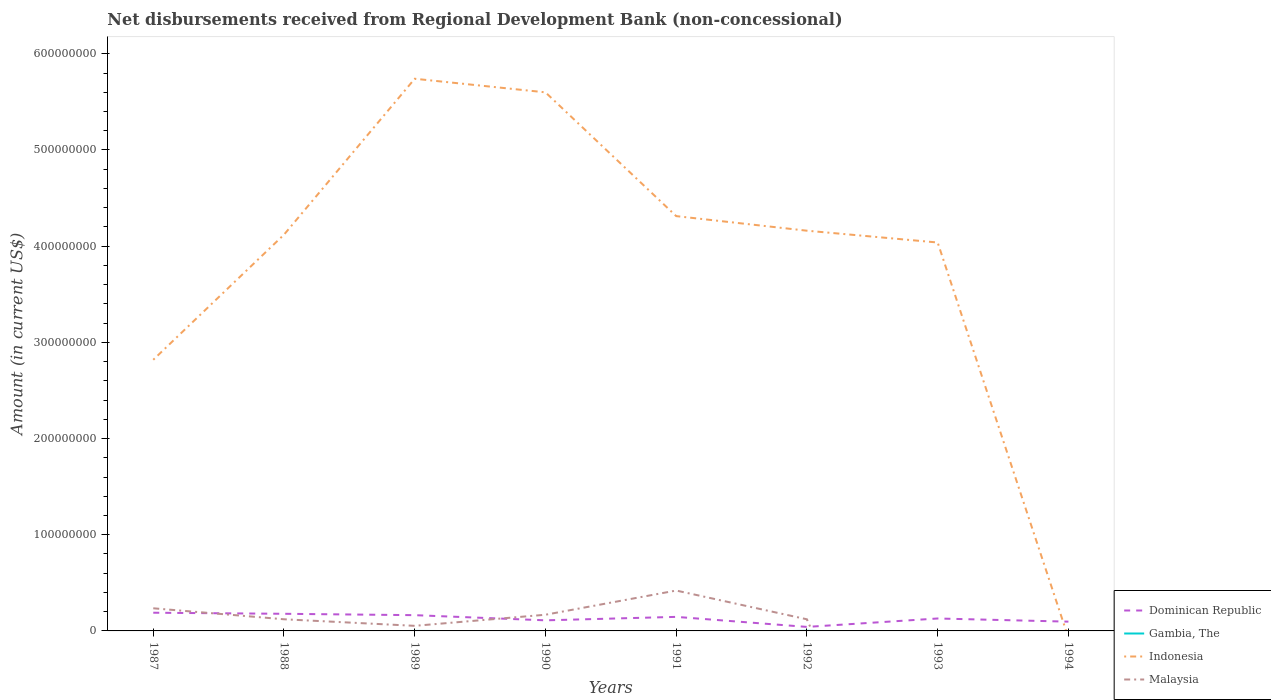Does the line corresponding to Indonesia intersect with the line corresponding to Gambia, The?
Your answer should be compact. Yes. Across all years, what is the maximum amount of disbursements received from Regional Development Bank in Gambia, The?
Make the answer very short. 0. What is the total amount of disbursements received from Regional Development Bank in Dominican Republic in the graph?
Keep it short and to the point. 1.77e+06. What is the difference between the highest and the second highest amount of disbursements received from Regional Development Bank in Malaysia?
Keep it short and to the point. 4.20e+07. What is the difference between the highest and the lowest amount of disbursements received from Regional Development Bank in Indonesia?
Keep it short and to the point. 6. How many lines are there?
Offer a very short reply. 4. How many years are there in the graph?
Offer a very short reply. 8. Does the graph contain any zero values?
Provide a succinct answer. Yes. Does the graph contain grids?
Your answer should be compact. No. What is the title of the graph?
Provide a short and direct response. Net disbursements received from Regional Development Bank (non-concessional). Does "Kiribati" appear as one of the legend labels in the graph?
Offer a terse response. No. What is the Amount (in current US$) in Dominican Republic in 1987?
Keep it short and to the point. 1.89e+07. What is the Amount (in current US$) of Indonesia in 1987?
Your answer should be very brief. 2.82e+08. What is the Amount (in current US$) of Malaysia in 1987?
Provide a succinct answer. 2.35e+07. What is the Amount (in current US$) of Dominican Republic in 1988?
Offer a very short reply. 1.78e+07. What is the Amount (in current US$) of Gambia, The in 1988?
Make the answer very short. 0. What is the Amount (in current US$) in Indonesia in 1988?
Your answer should be very brief. 4.12e+08. What is the Amount (in current US$) of Malaysia in 1988?
Your answer should be compact. 1.21e+07. What is the Amount (in current US$) of Dominican Republic in 1989?
Your response must be concise. 1.64e+07. What is the Amount (in current US$) in Gambia, The in 1989?
Offer a very short reply. 6000. What is the Amount (in current US$) of Indonesia in 1989?
Make the answer very short. 5.74e+08. What is the Amount (in current US$) of Malaysia in 1989?
Ensure brevity in your answer.  5.29e+06. What is the Amount (in current US$) of Dominican Republic in 1990?
Provide a succinct answer. 1.10e+07. What is the Amount (in current US$) in Indonesia in 1990?
Make the answer very short. 5.60e+08. What is the Amount (in current US$) of Malaysia in 1990?
Offer a very short reply. 1.68e+07. What is the Amount (in current US$) in Dominican Republic in 1991?
Ensure brevity in your answer.  1.46e+07. What is the Amount (in current US$) in Gambia, The in 1991?
Make the answer very short. 0. What is the Amount (in current US$) in Indonesia in 1991?
Ensure brevity in your answer.  4.31e+08. What is the Amount (in current US$) in Malaysia in 1991?
Give a very brief answer. 4.20e+07. What is the Amount (in current US$) of Dominican Republic in 1992?
Offer a terse response. 4.17e+06. What is the Amount (in current US$) of Gambia, The in 1992?
Your answer should be very brief. 1.03e+05. What is the Amount (in current US$) of Indonesia in 1992?
Your answer should be very brief. 4.16e+08. What is the Amount (in current US$) in Malaysia in 1992?
Keep it short and to the point. 1.21e+07. What is the Amount (in current US$) of Dominican Republic in 1993?
Provide a succinct answer. 1.29e+07. What is the Amount (in current US$) of Indonesia in 1993?
Give a very brief answer. 4.04e+08. What is the Amount (in current US$) in Dominican Republic in 1994?
Ensure brevity in your answer.  9.64e+06. What is the Amount (in current US$) in Indonesia in 1994?
Your answer should be compact. 0. What is the Amount (in current US$) in Malaysia in 1994?
Your answer should be very brief. 2.62e+06. Across all years, what is the maximum Amount (in current US$) in Dominican Republic?
Provide a short and direct response. 1.89e+07. Across all years, what is the maximum Amount (in current US$) of Gambia, The?
Your answer should be compact. 1.03e+05. Across all years, what is the maximum Amount (in current US$) in Indonesia?
Provide a short and direct response. 5.74e+08. Across all years, what is the maximum Amount (in current US$) of Malaysia?
Offer a very short reply. 4.20e+07. Across all years, what is the minimum Amount (in current US$) of Dominican Republic?
Offer a terse response. 4.17e+06. Across all years, what is the minimum Amount (in current US$) in Malaysia?
Your answer should be compact. 0. What is the total Amount (in current US$) in Dominican Republic in the graph?
Your answer should be very brief. 1.05e+08. What is the total Amount (in current US$) of Gambia, The in the graph?
Give a very brief answer. 1.09e+05. What is the total Amount (in current US$) of Indonesia in the graph?
Offer a terse response. 3.08e+09. What is the total Amount (in current US$) in Malaysia in the graph?
Your answer should be compact. 1.14e+08. What is the difference between the Amount (in current US$) in Dominican Republic in 1987 and that in 1988?
Make the answer very short. 1.11e+06. What is the difference between the Amount (in current US$) in Indonesia in 1987 and that in 1988?
Give a very brief answer. -1.30e+08. What is the difference between the Amount (in current US$) of Malaysia in 1987 and that in 1988?
Your answer should be compact. 1.14e+07. What is the difference between the Amount (in current US$) in Dominican Republic in 1987 and that in 1989?
Your response must be concise. 2.54e+06. What is the difference between the Amount (in current US$) in Indonesia in 1987 and that in 1989?
Ensure brevity in your answer.  -2.92e+08. What is the difference between the Amount (in current US$) of Malaysia in 1987 and that in 1989?
Your answer should be very brief. 1.82e+07. What is the difference between the Amount (in current US$) of Dominican Republic in 1987 and that in 1990?
Keep it short and to the point. 7.91e+06. What is the difference between the Amount (in current US$) of Indonesia in 1987 and that in 1990?
Your answer should be compact. -2.78e+08. What is the difference between the Amount (in current US$) in Malaysia in 1987 and that in 1990?
Provide a short and direct response. 6.70e+06. What is the difference between the Amount (in current US$) in Dominican Republic in 1987 and that in 1991?
Ensure brevity in your answer.  4.32e+06. What is the difference between the Amount (in current US$) in Indonesia in 1987 and that in 1991?
Keep it short and to the point. -1.49e+08. What is the difference between the Amount (in current US$) of Malaysia in 1987 and that in 1991?
Offer a terse response. -1.85e+07. What is the difference between the Amount (in current US$) in Dominican Republic in 1987 and that in 1992?
Offer a very short reply. 1.48e+07. What is the difference between the Amount (in current US$) in Indonesia in 1987 and that in 1992?
Make the answer very short. -1.34e+08. What is the difference between the Amount (in current US$) in Malaysia in 1987 and that in 1992?
Ensure brevity in your answer.  1.15e+07. What is the difference between the Amount (in current US$) of Dominican Republic in 1987 and that in 1993?
Ensure brevity in your answer.  5.99e+06. What is the difference between the Amount (in current US$) of Indonesia in 1987 and that in 1993?
Offer a terse response. -1.22e+08. What is the difference between the Amount (in current US$) in Dominican Republic in 1987 and that in 1994?
Provide a succinct answer. 9.28e+06. What is the difference between the Amount (in current US$) in Malaysia in 1987 and that in 1994?
Your answer should be compact. 2.09e+07. What is the difference between the Amount (in current US$) of Dominican Republic in 1988 and that in 1989?
Your response must be concise. 1.43e+06. What is the difference between the Amount (in current US$) of Indonesia in 1988 and that in 1989?
Your answer should be compact. -1.62e+08. What is the difference between the Amount (in current US$) in Malaysia in 1988 and that in 1989?
Your answer should be very brief. 6.82e+06. What is the difference between the Amount (in current US$) of Dominican Republic in 1988 and that in 1990?
Offer a terse response. 6.80e+06. What is the difference between the Amount (in current US$) of Indonesia in 1988 and that in 1990?
Keep it short and to the point. -1.48e+08. What is the difference between the Amount (in current US$) in Malaysia in 1988 and that in 1990?
Your answer should be compact. -4.72e+06. What is the difference between the Amount (in current US$) of Dominican Republic in 1988 and that in 1991?
Offer a very short reply. 3.21e+06. What is the difference between the Amount (in current US$) of Indonesia in 1988 and that in 1991?
Make the answer very short. -1.93e+07. What is the difference between the Amount (in current US$) of Malaysia in 1988 and that in 1991?
Ensure brevity in your answer.  -2.99e+07. What is the difference between the Amount (in current US$) in Dominican Republic in 1988 and that in 1992?
Ensure brevity in your answer.  1.36e+07. What is the difference between the Amount (in current US$) of Indonesia in 1988 and that in 1992?
Your answer should be very brief. -4.12e+06. What is the difference between the Amount (in current US$) of Malaysia in 1988 and that in 1992?
Give a very brief answer. 3.40e+04. What is the difference between the Amount (in current US$) in Dominican Republic in 1988 and that in 1993?
Your answer should be very brief. 4.88e+06. What is the difference between the Amount (in current US$) of Indonesia in 1988 and that in 1993?
Ensure brevity in your answer.  8.15e+06. What is the difference between the Amount (in current US$) in Dominican Republic in 1988 and that in 1994?
Your response must be concise. 8.17e+06. What is the difference between the Amount (in current US$) of Malaysia in 1988 and that in 1994?
Your answer should be compact. 9.48e+06. What is the difference between the Amount (in current US$) in Dominican Republic in 1989 and that in 1990?
Give a very brief answer. 5.37e+06. What is the difference between the Amount (in current US$) of Indonesia in 1989 and that in 1990?
Ensure brevity in your answer.  1.41e+07. What is the difference between the Amount (in current US$) in Malaysia in 1989 and that in 1990?
Give a very brief answer. -1.15e+07. What is the difference between the Amount (in current US$) of Dominican Republic in 1989 and that in 1991?
Provide a short and direct response. 1.77e+06. What is the difference between the Amount (in current US$) of Indonesia in 1989 and that in 1991?
Ensure brevity in your answer.  1.43e+08. What is the difference between the Amount (in current US$) of Malaysia in 1989 and that in 1991?
Your response must be concise. -3.67e+07. What is the difference between the Amount (in current US$) in Dominican Republic in 1989 and that in 1992?
Your answer should be compact. 1.22e+07. What is the difference between the Amount (in current US$) of Gambia, The in 1989 and that in 1992?
Offer a very short reply. -9.70e+04. What is the difference between the Amount (in current US$) in Indonesia in 1989 and that in 1992?
Your answer should be very brief. 1.58e+08. What is the difference between the Amount (in current US$) in Malaysia in 1989 and that in 1992?
Your response must be concise. -6.78e+06. What is the difference between the Amount (in current US$) of Dominican Republic in 1989 and that in 1993?
Offer a very short reply. 3.45e+06. What is the difference between the Amount (in current US$) in Indonesia in 1989 and that in 1993?
Your answer should be very brief. 1.70e+08. What is the difference between the Amount (in current US$) of Dominican Republic in 1989 and that in 1994?
Keep it short and to the point. 6.74e+06. What is the difference between the Amount (in current US$) in Malaysia in 1989 and that in 1994?
Your response must be concise. 2.67e+06. What is the difference between the Amount (in current US$) in Dominican Republic in 1990 and that in 1991?
Give a very brief answer. -3.60e+06. What is the difference between the Amount (in current US$) of Indonesia in 1990 and that in 1991?
Your answer should be compact. 1.29e+08. What is the difference between the Amount (in current US$) of Malaysia in 1990 and that in 1991?
Provide a succinct answer. -2.52e+07. What is the difference between the Amount (in current US$) of Dominican Republic in 1990 and that in 1992?
Give a very brief answer. 6.84e+06. What is the difference between the Amount (in current US$) in Indonesia in 1990 and that in 1992?
Your answer should be very brief. 1.44e+08. What is the difference between the Amount (in current US$) in Malaysia in 1990 and that in 1992?
Give a very brief answer. 4.75e+06. What is the difference between the Amount (in current US$) of Dominican Republic in 1990 and that in 1993?
Your answer should be compact. -1.92e+06. What is the difference between the Amount (in current US$) of Indonesia in 1990 and that in 1993?
Ensure brevity in your answer.  1.56e+08. What is the difference between the Amount (in current US$) of Dominican Republic in 1990 and that in 1994?
Make the answer very short. 1.37e+06. What is the difference between the Amount (in current US$) in Malaysia in 1990 and that in 1994?
Provide a succinct answer. 1.42e+07. What is the difference between the Amount (in current US$) of Dominican Republic in 1991 and that in 1992?
Give a very brief answer. 1.04e+07. What is the difference between the Amount (in current US$) of Indonesia in 1991 and that in 1992?
Offer a very short reply. 1.52e+07. What is the difference between the Amount (in current US$) of Malaysia in 1991 and that in 1992?
Offer a terse response. 2.99e+07. What is the difference between the Amount (in current US$) in Dominican Republic in 1991 and that in 1993?
Your response must be concise. 1.68e+06. What is the difference between the Amount (in current US$) of Indonesia in 1991 and that in 1993?
Provide a short and direct response. 2.74e+07. What is the difference between the Amount (in current US$) of Dominican Republic in 1991 and that in 1994?
Your answer should be very brief. 4.96e+06. What is the difference between the Amount (in current US$) of Malaysia in 1991 and that in 1994?
Provide a succinct answer. 3.94e+07. What is the difference between the Amount (in current US$) in Dominican Republic in 1992 and that in 1993?
Your answer should be very brief. -8.76e+06. What is the difference between the Amount (in current US$) in Indonesia in 1992 and that in 1993?
Your response must be concise. 1.23e+07. What is the difference between the Amount (in current US$) of Dominican Republic in 1992 and that in 1994?
Ensure brevity in your answer.  -5.47e+06. What is the difference between the Amount (in current US$) in Malaysia in 1992 and that in 1994?
Your answer should be very brief. 9.45e+06. What is the difference between the Amount (in current US$) of Dominican Republic in 1993 and that in 1994?
Keep it short and to the point. 3.29e+06. What is the difference between the Amount (in current US$) in Dominican Republic in 1987 and the Amount (in current US$) in Indonesia in 1988?
Give a very brief answer. -3.93e+08. What is the difference between the Amount (in current US$) in Dominican Republic in 1987 and the Amount (in current US$) in Malaysia in 1988?
Keep it short and to the point. 6.81e+06. What is the difference between the Amount (in current US$) of Indonesia in 1987 and the Amount (in current US$) of Malaysia in 1988?
Provide a short and direct response. 2.70e+08. What is the difference between the Amount (in current US$) in Dominican Republic in 1987 and the Amount (in current US$) in Gambia, The in 1989?
Give a very brief answer. 1.89e+07. What is the difference between the Amount (in current US$) of Dominican Republic in 1987 and the Amount (in current US$) of Indonesia in 1989?
Offer a very short reply. -5.55e+08. What is the difference between the Amount (in current US$) of Dominican Republic in 1987 and the Amount (in current US$) of Malaysia in 1989?
Ensure brevity in your answer.  1.36e+07. What is the difference between the Amount (in current US$) of Indonesia in 1987 and the Amount (in current US$) of Malaysia in 1989?
Provide a succinct answer. 2.77e+08. What is the difference between the Amount (in current US$) of Dominican Republic in 1987 and the Amount (in current US$) of Indonesia in 1990?
Provide a succinct answer. -5.41e+08. What is the difference between the Amount (in current US$) of Dominican Republic in 1987 and the Amount (in current US$) of Malaysia in 1990?
Provide a succinct answer. 2.09e+06. What is the difference between the Amount (in current US$) of Indonesia in 1987 and the Amount (in current US$) of Malaysia in 1990?
Your answer should be very brief. 2.65e+08. What is the difference between the Amount (in current US$) of Dominican Republic in 1987 and the Amount (in current US$) of Indonesia in 1991?
Your answer should be very brief. -4.12e+08. What is the difference between the Amount (in current US$) of Dominican Republic in 1987 and the Amount (in current US$) of Malaysia in 1991?
Your response must be concise. -2.31e+07. What is the difference between the Amount (in current US$) of Indonesia in 1987 and the Amount (in current US$) of Malaysia in 1991?
Provide a succinct answer. 2.40e+08. What is the difference between the Amount (in current US$) in Dominican Republic in 1987 and the Amount (in current US$) in Gambia, The in 1992?
Your answer should be compact. 1.88e+07. What is the difference between the Amount (in current US$) of Dominican Republic in 1987 and the Amount (in current US$) of Indonesia in 1992?
Keep it short and to the point. -3.97e+08. What is the difference between the Amount (in current US$) of Dominican Republic in 1987 and the Amount (in current US$) of Malaysia in 1992?
Ensure brevity in your answer.  6.84e+06. What is the difference between the Amount (in current US$) in Indonesia in 1987 and the Amount (in current US$) in Malaysia in 1992?
Ensure brevity in your answer.  2.70e+08. What is the difference between the Amount (in current US$) in Dominican Republic in 1987 and the Amount (in current US$) in Indonesia in 1993?
Provide a short and direct response. -3.85e+08. What is the difference between the Amount (in current US$) of Dominican Republic in 1987 and the Amount (in current US$) of Malaysia in 1994?
Ensure brevity in your answer.  1.63e+07. What is the difference between the Amount (in current US$) of Indonesia in 1987 and the Amount (in current US$) of Malaysia in 1994?
Your answer should be very brief. 2.79e+08. What is the difference between the Amount (in current US$) of Dominican Republic in 1988 and the Amount (in current US$) of Gambia, The in 1989?
Your answer should be very brief. 1.78e+07. What is the difference between the Amount (in current US$) of Dominican Republic in 1988 and the Amount (in current US$) of Indonesia in 1989?
Make the answer very short. -5.56e+08. What is the difference between the Amount (in current US$) in Dominican Republic in 1988 and the Amount (in current US$) in Malaysia in 1989?
Ensure brevity in your answer.  1.25e+07. What is the difference between the Amount (in current US$) in Indonesia in 1988 and the Amount (in current US$) in Malaysia in 1989?
Provide a succinct answer. 4.07e+08. What is the difference between the Amount (in current US$) in Dominican Republic in 1988 and the Amount (in current US$) in Indonesia in 1990?
Your answer should be very brief. -5.42e+08. What is the difference between the Amount (in current US$) of Dominican Republic in 1988 and the Amount (in current US$) of Malaysia in 1990?
Offer a very short reply. 9.82e+05. What is the difference between the Amount (in current US$) in Indonesia in 1988 and the Amount (in current US$) in Malaysia in 1990?
Ensure brevity in your answer.  3.95e+08. What is the difference between the Amount (in current US$) in Dominican Republic in 1988 and the Amount (in current US$) in Indonesia in 1991?
Provide a succinct answer. -4.13e+08. What is the difference between the Amount (in current US$) of Dominican Republic in 1988 and the Amount (in current US$) of Malaysia in 1991?
Provide a short and direct response. -2.42e+07. What is the difference between the Amount (in current US$) in Indonesia in 1988 and the Amount (in current US$) in Malaysia in 1991?
Your response must be concise. 3.70e+08. What is the difference between the Amount (in current US$) in Dominican Republic in 1988 and the Amount (in current US$) in Gambia, The in 1992?
Keep it short and to the point. 1.77e+07. What is the difference between the Amount (in current US$) of Dominican Republic in 1988 and the Amount (in current US$) of Indonesia in 1992?
Ensure brevity in your answer.  -3.98e+08. What is the difference between the Amount (in current US$) in Dominican Republic in 1988 and the Amount (in current US$) in Malaysia in 1992?
Offer a terse response. 5.74e+06. What is the difference between the Amount (in current US$) of Indonesia in 1988 and the Amount (in current US$) of Malaysia in 1992?
Offer a very short reply. 4.00e+08. What is the difference between the Amount (in current US$) of Dominican Republic in 1988 and the Amount (in current US$) of Indonesia in 1993?
Your answer should be compact. -3.86e+08. What is the difference between the Amount (in current US$) of Dominican Republic in 1988 and the Amount (in current US$) of Malaysia in 1994?
Provide a short and direct response. 1.52e+07. What is the difference between the Amount (in current US$) in Indonesia in 1988 and the Amount (in current US$) in Malaysia in 1994?
Provide a short and direct response. 4.09e+08. What is the difference between the Amount (in current US$) of Dominican Republic in 1989 and the Amount (in current US$) of Indonesia in 1990?
Provide a short and direct response. -5.44e+08. What is the difference between the Amount (in current US$) in Dominican Republic in 1989 and the Amount (in current US$) in Malaysia in 1990?
Offer a very short reply. -4.51e+05. What is the difference between the Amount (in current US$) in Gambia, The in 1989 and the Amount (in current US$) in Indonesia in 1990?
Provide a succinct answer. -5.60e+08. What is the difference between the Amount (in current US$) of Gambia, The in 1989 and the Amount (in current US$) of Malaysia in 1990?
Your answer should be very brief. -1.68e+07. What is the difference between the Amount (in current US$) of Indonesia in 1989 and the Amount (in current US$) of Malaysia in 1990?
Provide a succinct answer. 5.57e+08. What is the difference between the Amount (in current US$) in Dominican Republic in 1989 and the Amount (in current US$) in Indonesia in 1991?
Offer a terse response. -4.15e+08. What is the difference between the Amount (in current US$) in Dominican Republic in 1989 and the Amount (in current US$) in Malaysia in 1991?
Give a very brief answer. -2.56e+07. What is the difference between the Amount (in current US$) of Gambia, The in 1989 and the Amount (in current US$) of Indonesia in 1991?
Your response must be concise. -4.31e+08. What is the difference between the Amount (in current US$) in Gambia, The in 1989 and the Amount (in current US$) in Malaysia in 1991?
Provide a short and direct response. -4.20e+07. What is the difference between the Amount (in current US$) in Indonesia in 1989 and the Amount (in current US$) in Malaysia in 1991?
Your answer should be very brief. 5.32e+08. What is the difference between the Amount (in current US$) in Dominican Republic in 1989 and the Amount (in current US$) in Gambia, The in 1992?
Give a very brief answer. 1.63e+07. What is the difference between the Amount (in current US$) in Dominican Republic in 1989 and the Amount (in current US$) in Indonesia in 1992?
Offer a terse response. -4.00e+08. What is the difference between the Amount (in current US$) in Dominican Republic in 1989 and the Amount (in current US$) in Malaysia in 1992?
Your answer should be very brief. 4.30e+06. What is the difference between the Amount (in current US$) of Gambia, The in 1989 and the Amount (in current US$) of Indonesia in 1992?
Offer a very short reply. -4.16e+08. What is the difference between the Amount (in current US$) in Gambia, The in 1989 and the Amount (in current US$) in Malaysia in 1992?
Your answer should be compact. -1.21e+07. What is the difference between the Amount (in current US$) of Indonesia in 1989 and the Amount (in current US$) of Malaysia in 1992?
Ensure brevity in your answer.  5.62e+08. What is the difference between the Amount (in current US$) of Dominican Republic in 1989 and the Amount (in current US$) of Indonesia in 1993?
Your answer should be compact. -3.87e+08. What is the difference between the Amount (in current US$) of Gambia, The in 1989 and the Amount (in current US$) of Indonesia in 1993?
Make the answer very short. -4.04e+08. What is the difference between the Amount (in current US$) in Dominican Republic in 1989 and the Amount (in current US$) in Malaysia in 1994?
Provide a succinct answer. 1.38e+07. What is the difference between the Amount (in current US$) of Gambia, The in 1989 and the Amount (in current US$) of Malaysia in 1994?
Provide a short and direct response. -2.62e+06. What is the difference between the Amount (in current US$) in Indonesia in 1989 and the Amount (in current US$) in Malaysia in 1994?
Make the answer very short. 5.71e+08. What is the difference between the Amount (in current US$) in Dominican Republic in 1990 and the Amount (in current US$) in Indonesia in 1991?
Keep it short and to the point. -4.20e+08. What is the difference between the Amount (in current US$) of Dominican Republic in 1990 and the Amount (in current US$) of Malaysia in 1991?
Your response must be concise. -3.10e+07. What is the difference between the Amount (in current US$) in Indonesia in 1990 and the Amount (in current US$) in Malaysia in 1991?
Offer a very short reply. 5.18e+08. What is the difference between the Amount (in current US$) of Dominican Republic in 1990 and the Amount (in current US$) of Gambia, The in 1992?
Your answer should be very brief. 1.09e+07. What is the difference between the Amount (in current US$) in Dominican Republic in 1990 and the Amount (in current US$) in Indonesia in 1992?
Make the answer very short. -4.05e+08. What is the difference between the Amount (in current US$) in Dominican Republic in 1990 and the Amount (in current US$) in Malaysia in 1992?
Ensure brevity in your answer.  -1.07e+06. What is the difference between the Amount (in current US$) of Indonesia in 1990 and the Amount (in current US$) of Malaysia in 1992?
Offer a terse response. 5.48e+08. What is the difference between the Amount (in current US$) of Dominican Republic in 1990 and the Amount (in current US$) of Indonesia in 1993?
Your response must be concise. -3.93e+08. What is the difference between the Amount (in current US$) in Dominican Republic in 1990 and the Amount (in current US$) in Malaysia in 1994?
Keep it short and to the point. 8.38e+06. What is the difference between the Amount (in current US$) in Indonesia in 1990 and the Amount (in current US$) in Malaysia in 1994?
Keep it short and to the point. 5.57e+08. What is the difference between the Amount (in current US$) in Dominican Republic in 1991 and the Amount (in current US$) in Gambia, The in 1992?
Make the answer very short. 1.45e+07. What is the difference between the Amount (in current US$) in Dominican Republic in 1991 and the Amount (in current US$) in Indonesia in 1992?
Offer a very short reply. -4.01e+08. What is the difference between the Amount (in current US$) of Dominican Republic in 1991 and the Amount (in current US$) of Malaysia in 1992?
Provide a short and direct response. 2.53e+06. What is the difference between the Amount (in current US$) in Indonesia in 1991 and the Amount (in current US$) in Malaysia in 1992?
Provide a short and direct response. 4.19e+08. What is the difference between the Amount (in current US$) of Dominican Republic in 1991 and the Amount (in current US$) of Indonesia in 1993?
Your response must be concise. -3.89e+08. What is the difference between the Amount (in current US$) of Dominican Republic in 1991 and the Amount (in current US$) of Malaysia in 1994?
Your answer should be compact. 1.20e+07. What is the difference between the Amount (in current US$) of Indonesia in 1991 and the Amount (in current US$) of Malaysia in 1994?
Your answer should be compact. 4.29e+08. What is the difference between the Amount (in current US$) of Dominican Republic in 1992 and the Amount (in current US$) of Indonesia in 1993?
Offer a very short reply. -4.00e+08. What is the difference between the Amount (in current US$) in Gambia, The in 1992 and the Amount (in current US$) in Indonesia in 1993?
Your response must be concise. -4.04e+08. What is the difference between the Amount (in current US$) of Dominican Republic in 1992 and the Amount (in current US$) of Malaysia in 1994?
Offer a terse response. 1.55e+06. What is the difference between the Amount (in current US$) of Gambia, The in 1992 and the Amount (in current US$) of Malaysia in 1994?
Provide a short and direct response. -2.52e+06. What is the difference between the Amount (in current US$) in Indonesia in 1992 and the Amount (in current US$) in Malaysia in 1994?
Provide a short and direct response. 4.13e+08. What is the difference between the Amount (in current US$) in Dominican Republic in 1993 and the Amount (in current US$) in Malaysia in 1994?
Offer a terse response. 1.03e+07. What is the difference between the Amount (in current US$) in Indonesia in 1993 and the Amount (in current US$) in Malaysia in 1994?
Your response must be concise. 4.01e+08. What is the average Amount (in current US$) of Dominican Republic per year?
Make the answer very short. 1.32e+07. What is the average Amount (in current US$) in Gambia, The per year?
Make the answer very short. 1.36e+04. What is the average Amount (in current US$) in Indonesia per year?
Give a very brief answer. 3.85e+08. What is the average Amount (in current US$) of Malaysia per year?
Give a very brief answer. 1.43e+07. In the year 1987, what is the difference between the Amount (in current US$) of Dominican Republic and Amount (in current US$) of Indonesia?
Ensure brevity in your answer.  -2.63e+08. In the year 1987, what is the difference between the Amount (in current US$) of Dominican Republic and Amount (in current US$) of Malaysia?
Give a very brief answer. -4.61e+06. In the year 1987, what is the difference between the Amount (in current US$) in Indonesia and Amount (in current US$) in Malaysia?
Provide a succinct answer. 2.58e+08. In the year 1988, what is the difference between the Amount (in current US$) of Dominican Republic and Amount (in current US$) of Indonesia?
Make the answer very short. -3.94e+08. In the year 1988, what is the difference between the Amount (in current US$) of Dominican Republic and Amount (in current US$) of Malaysia?
Keep it short and to the point. 5.70e+06. In the year 1988, what is the difference between the Amount (in current US$) of Indonesia and Amount (in current US$) of Malaysia?
Provide a succinct answer. 4.00e+08. In the year 1989, what is the difference between the Amount (in current US$) in Dominican Republic and Amount (in current US$) in Gambia, The?
Make the answer very short. 1.64e+07. In the year 1989, what is the difference between the Amount (in current US$) in Dominican Republic and Amount (in current US$) in Indonesia?
Your answer should be compact. -5.58e+08. In the year 1989, what is the difference between the Amount (in current US$) in Dominican Republic and Amount (in current US$) in Malaysia?
Provide a succinct answer. 1.11e+07. In the year 1989, what is the difference between the Amount (in current US$) of Gambia, The and Amount (in current US$) of Indonesia?
Provide a succinct answer. -5.74e+08. In the year 1989, what is the difference between the Amount (in current US$) of Gambia, The and Amount (in current US$) of Malaysia?
Offer a terse response. -5.28e+06. In the year 1989, what is the difference between the Amount (in current US$) of Indonesia and Amount (in current US$) of Malaysia?
Keep it short and to the point. 5.69e+08. In the year 1990, what is the difference between the Amount (in current US$) in Dominican Republic and Amount (in current US$) in Indonesia?
Give a very brief answer. -5.49e+08. In the year 1990, what is the difference between the Amount (in current US$) of Dominican Republic and Amount (in current US$) of Malaysia?
Give a very brief answer. -5.82e+06. In the year 1990, what is the difference between the Amount (in current US$) in Indonesia and Amount (in current US$) in Malaysia?
Your response must be concise. 5.43e+08. In the year 1991, what is the difference between the Amount (in current US$) of Dominican Republic and Amount (in current US$) of Indonesia?
Keep it short and to the point. -4.17e+08. In the year 1991, what is the difference between the Amount (in current US$) of Dominican Republic and Amount (in current US$) of Malaysia?
Offer a very short reply. -2.74e+07. In the year 1991, what is the difference between the Amount (in current US$) of Indonesia and Amount (in current US$) of Malaysia?
Provide a short and direct response. 3.89e+08. In the year 1992, what is the difference between the Amount (in current US$) of Dominican Republic and Amount (in current US$) of Gambia, The?
Ensure brevity in your answer.  4.07e+06. In the year 1992, what is the difference between the Amount (in current US$) in Dominican Republic and Amount (in current US$) in Indonesia?
Provide a short and direct response. -4.12e+08. In the year 1992, what is the difference between the Amount (in current US$) of Dominican Republic and Amount (in current US$) of Malaysia?
Keep it short and to the point. -7.90e+06. In the year 1992, what is the difference between the Amount (in current US$) in Gambia, The and Amount (in current US$) in Indonesia?
Your response must be concise. -4.16e+08. In the year 1992, what is the difference between the Amount (in current US$) of Gambia, The and Amount (in current US$) of Malaysia?
Give a very brief answer. -1.20e+07. In the year 1992, what is the difference between the Amount (in current US$) in Indonesia and Amount (in current US$) in Malaysia?
Provide a short and direct response. 4.04e+08. In the year 1993, what is the difference between the Amount (in current US$) of Dominican Republic and Amount (in current US$) of Indonesia?
Ensure brevity in your answer.  -3.91e+08. In the year 1994, what is the difference between the Amount (in current US$) in Dominican Republic and Amount (in current US$) in Malaysia?
Offer a terse response. 7.02e+06. What is the ratio of the Amount (in current US$) in Dominican Republic in 1987 to that in 1988?
Your answer should be very brief. 1.06. What is the ratio of the Amount (in current US$) of Indonesia in 1987 to that in 1988?
Provide a succinct answer. 0.68. What is the ratio of the Amount (in current US$) in Malaysia in 1987 to that in 1988?
Offer a very short reply. 1.94. What is the ratio of the Amount (in current US$) of Dominican Republic in 1987 to that in 1989?
Ensure brevity in your answer.  1.16. What is the ratio of the Amount (in current US$) of Indonesia in 1987 to that in 1989?
Your answer should be very brief. 0.49. What is the ratio of the Amount (in current US$) in Malaysia in 1987 to that in 1989?
Provide a short and direct response. 4.45. What is the ratio of the Amount (in current US$) in Dominican Republic in 1987 to that in 1990?
Ensure brevity in your answer.  1.72. What is the ratio of the Amount (in current US$) of Indonesia in 1987 to that in 1990?
Ensure brevity in your answer.  0.5. What is the ratio of the Amount (in current US$) of Malaysia in 1987 to that in 1990?
Keep it short and to the point. 1.4. What is the ratio of the Amount (in current US$) in Dominican Republic in 1987 to that in 1991?
Your answer should be compact. 1.3. What is the ratio of the Amount (in current US$) of Indonesia in 1987 to that in 1991?
Your answer should be compact. 0.65. What is the ratio of the Amount (in current US$) of Malaysia in 1987 to that in 1991?
Provide a short and direct response. 0.56. What is the ratio of the Amount (in current US$) of Dominican Republic in 1987 to that in 1992?
Give a very brief answer. 4.54. What is the ratio of the Amount (in current US$) of Indonesia in 1987 to that in 1992?
Offer a very short reply. 0.68. What is the ratio of the Amount (in current US$) in Malaysia in 1987 to that in 1992?
Ensure brevity in your answer.  1.95. What is the ratio of the Amount (in current US$) of Dominican Republic in 1987 to that in 1993?
Your answer should be compact. 1.46. What is the ratio of the Amount (in current US$) in Indonesia in 1987 to that in 1993?
Your answer should be compact. 0.7. What is the ratio of the Amount (in current US$) in Dominican Republic in 1987 to that in 1994?
Give a very brief answer. 1.96. What is the ratio of the Amount (in current US$) in Malaysia in 1987 to that in 1994?
Ensure brevity in your answer.  8.97. What is the ratio of the Amount (in current US$) of Dominican Republic in 1988 to that in 1989?
Your answer should be very brief. 1.09. What is the ratio of the Amount (in current US$) of Indonesia in 1988 to that in 1989?
Provide a succinct answer. 0.72. What is the ratio of the Amount (in current US$) in Malaysia in 1988 to that in 1989?
Keep it short and to the point. 2.29. What is the ratio of the Amount (in current US$) of Dominican Republic in 1988 to that in 1990?
Ensure brevity in your answer.  1.62. What is the ratio of the Amount (in current US$) in Indonesia in 1988 to that in 1990?
Your answer should be very brief. 0.74. What is the ratio of the Amount (in current US$) in Malaysia in 1988 to that in 1990?
Keep it short and to the point. 0.72. What is the ratio of the Amount (in current US$) in Dominican Republic in 1988 to that in 1991?
Ensure brevity in your answer.  1.22. What is the ratio of the Amount (in current US$) in Indonesia in 1988 to that in 1991?
Make the answer very short. 0.96. What is the ratio of the Amount (in current US$) of Malaysia in 1988 to that in 1991?
Your answer should be compact. 0.29. What is the ratio of the Amount (in current US$) of Dominican Republic in 1988 to that in 1992?
Keep it short and to the point. 4.27. What is the ratio of the Amount (in current US$) in Dominican Republic in 1988 to that in 1993?
Provide a succinct answer. 1.38. What is the ratio of the Amount (in current US$) of Indonesia in 1988 to that in 1993?
Provide a short and direct response. 1.02. What is the ratio of the Amount (in current US$) of Dominican Republic in 1988 to that in 1994?
Your answer should be very brief. 1.85. What is the ratio of the Amount (in current US$) in Malaysia in 1988 to that in 1994?
Keep it short and to the point. 4.61. What is the ratio of the Amount (in current US$) of Dominican Republic in 1989 to that in 1990?
Your answer should be very brief. 1.49. What is the ratio of the Amount (in current US$) in Indonesia in 1989 to that in 1990?
Your answer should be compact. 1.03. What is the ratio of the Amount (in current US$) in Malaysia in 1989 to that in 1990?
Your answer should be compact. 0.31. What is the ratio of the Amount (in current US$) of Dominican Republic in 1989 to that in 1991?
Your response must be concise. 1.12. What is the ratio of the Amount (in current US$) of Indonesia in 1989 to that in 1991?
Make the answer very short. 1.33. What is the ratio of the Amount (in current US$) in Malaysia in 1989 to that in 1991?
Provide a succinct answer. 0.13. What is the ratio of the Amount (in current US$) of Dominican Republic in 1989 to that in 1992?
Keep it short and to the point. 3.93. What is the ratio of the Amount (in current US$) in Gambia, The in 1989 to that in 1992?
Give a very brief answer. 0.06. What is the ratio of the Amount (in current US$) of Indonesia in 1989 to that in 1992?
Provide a short and direct response. 1.38. What is the ratio of the Amount (in current US$) of Malaysia in 1989 to that in 1992?
Your answer should be very brief. 0.44. What is the ratio of the Amount (in current US$) in Dominican Republic in 1989 to that in 1993?
Your response must be concise. 1.27. What is the ratio of the Amount (in current US$) in Indonesia in 1989 to that in 1993?
Provide a short and direct response. 1.42. What is the ratio of the Amount (in current US$) in Dominican Republic in 1989 to that in 1994?
Your response must be concise. 1.7. What is the ratio of the Amount (in current US$) in Malaysia in 1989 to that in 1994?
Provide a succinct answer. 2.02. What is the ratio of the Amount (in current US$) in Dominican Republic in 1990 to that in 1991?
Make the answer very short. 0.75. What is the ratio of the Amount (in current US$) in Indonesia in 1990 to that in 1991?
Your response must be concise. 1.3. What is the ratio of the Amount (in current US$) in Malaysia in 1990 to that in 1991?
Keep it short and to the point. 0.4. What is the ratio of the Amount (in current US$) of Dominican Republic in 1990 to that in 1992?
Your response must be concise. 2.64. What is the ratio of the Amount (in current US$) of Indonesia in 1990 to that in 1992?
Your answer should be compact. 1.35. What is the ratio of the Amount (in current US$) in Malaysia in 1990 to that in 1992?
Your answer should be compact. 1.39. What is the ratio of the Amount (in current US$) of Dominican Republic in 1990 to that in 1993?
Offer a terse response. 0.85. What is the ratio of the Amount (in current US$) in Indonesia in 1990 to that in 1993?
Make the answer very short. 1.39. What is the ratio of the Amount (in current US$) of Dominican Republic in 1990 to that in 1994?
Offer a terse response. 1.14. What is the ratio of the Amount (in current US$) in Malaysia in 1990 to that in 1994?
Provide a succinct answer. 6.41. What is the ratio of the Amount (in current US$) of Dominican Republic in 1991 to that in 1992?
Make the answer very short. 3.5. What is the ratio of the Amount (in current US$) of Indonesia in 1991 to that in 1992?
Ensure brevity in your answer.  1.04. What is the ratio of the Amount (in current US$) of Malaysia in 1991 to that in 1992?
Provide a short and direct response. 3.48. What is the ratio of the Amount (in current US$) of Dominican Republic in 1991 to that in 1993?
Your response must be concise. 1.13. What is the ratio of the Amount (in current US$) in Indonesia in 1991 to that in 1993?
Your response must be concise. 1.07. What is the ratio of the Amount (in current US$) of Dominican Republic in 1991 to that in 1994?
Keep it short and to the point. 1.51. What is the ratio of the Amount (in current US$) of Malaysia in 1991 to that in 1994?
Provide a succinct answer. 16. What is the ratio of the Amount (in current US$) of Dominican Republic in 1992 to that in 1993?
Offer a very short reply. 0.32. What is the ratio of the Amount (in current US$) in Indonesia in 1992 to that in 1993?
Ensure brevity in your answer.  1.03. What is the ratio of the Amount (in current US$) of Dominican Republic in 1992 to that in 1994?
Keep it short and to the point. 0.43. What is the ratio of the Amount (in current US$) of Malaysia in 1992 to that in 1994?
Ensure brevity in your answer.  4.6. What is the ratio of the Amount (in current US$) in Dominican Republic in 1993 to that in 1994?
Your response must be concise. 1.34. What is the difference between the highest and the second highest Amount (in current US$) in Dominican Republic?
Make the answer very short. 1.11e+06. What is the difference between the highest and the second highest Amount (in current US$) of Indonesia?
Provide a short and direct response. 1.41e+07. What is the difference between the highest and the second highest Amount (in current US$) in Malaysia?
Your response must be concise. 1.85e+07. What is the difference between the highest and the lowest Amount (in current US$) in Dominican Republic?
Make the answer very short. 1.48e+07. What is the difference between the highest and the lowest Amount (in current US$) in Gambia, The?
Your response must be concise. 1.03e+05. What is the difference between the highest and the lowest Amount (in current US$) in Indonesia?
Your response must be concise. 5.74e+08. What is the difference between the highest and the lowest Amount (in current US$) in Malaysia?
Your response must be concise. 4.20e+07. 